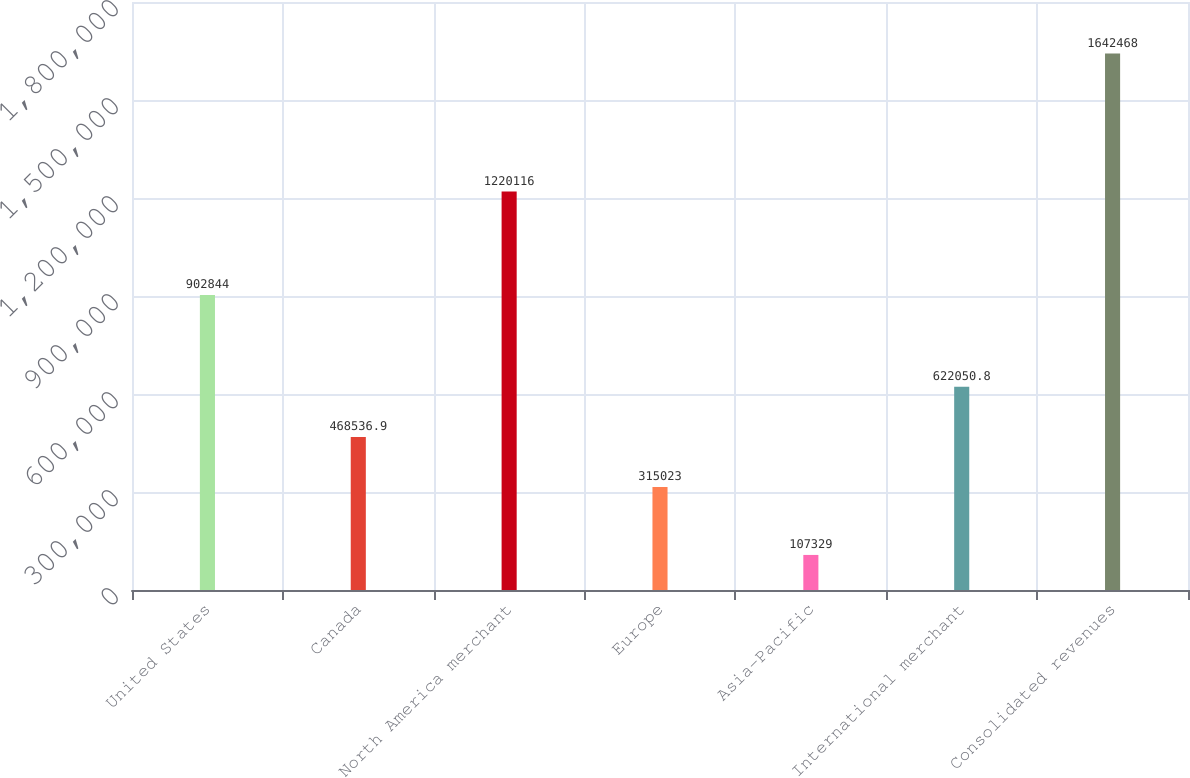Convert chart. <chart><loc_0><loc_0><loc_500><loc_500><bar_chart><fcel>United States<fcel>Canada<fcel>North America merchant<fcel>Europe<fcel>Asia-Pacific<fcel>International merchant<fcel>Consolidated revenues<nl><fcel>902844<fcel>468537<fcel>1.22012e+06<fcel>315023<fcel>107329<fcel>622051<fcel>1.64247e+06<nl></chart> 